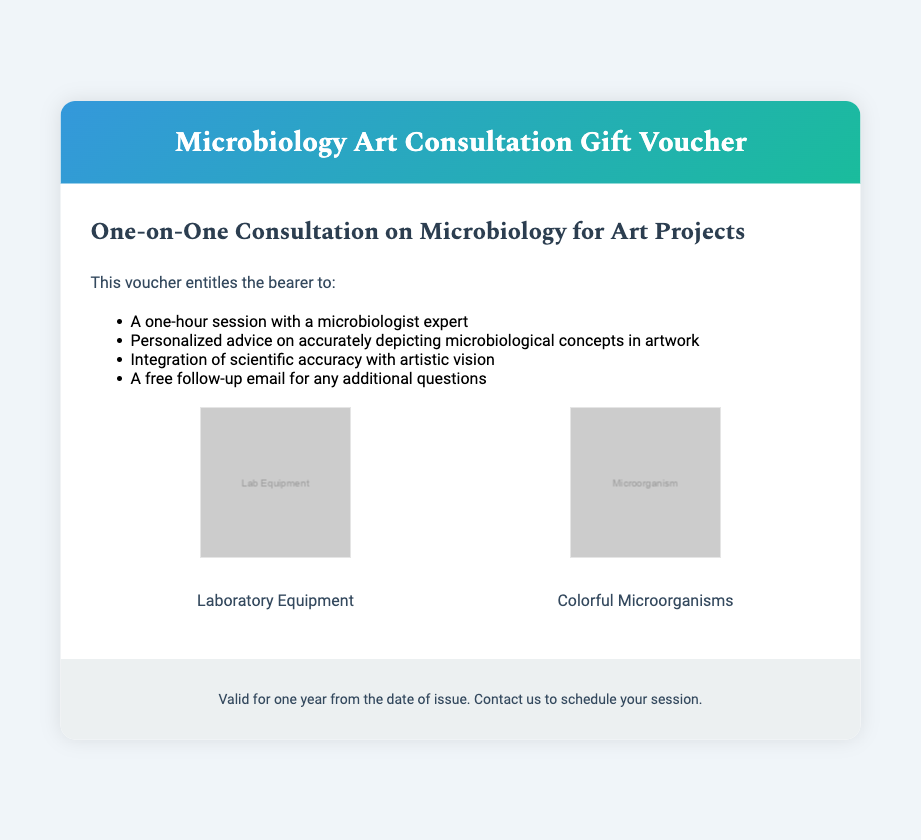What is the title of the voucher? The title is displayed prominently at the top of the document, stating the purpose of the voucher.
Answer: Microbiology Art Consultation Gift Voucher How long is the consultation session? The document specifies the duration of the session offered by the voucher.
Answer: One hour What type of follow-up is included? The document mentions a specific type of follow-up that is offered to the voucher bearer.
Answer: Free follow-up email What images are featured in the design elements? The document describes the images included in the design elements section, representing pervading themes of the voucher.
Answer: Laboratory Equipment and Colorful Microorganisms What is the validity period of the voucher? The footer of the voucher indicates how long the voucher is valid for.
Answer: One year from the date of issue What kind of advice is provided during the consultation? The document highlights the type of expertise offered in the consultation session.
Answer: Personalized advice on accurately depicting microbiological concepts in artwork What key aspect of art does this voucher emphasize? The document includes the main focus of the consultation in relation to artistic practice.
Answer: Integration of scientific accuracy with artistic vision What is the background color of the voucher? The background color is described in the body style section of the document.
Answer: #f0f5f9 